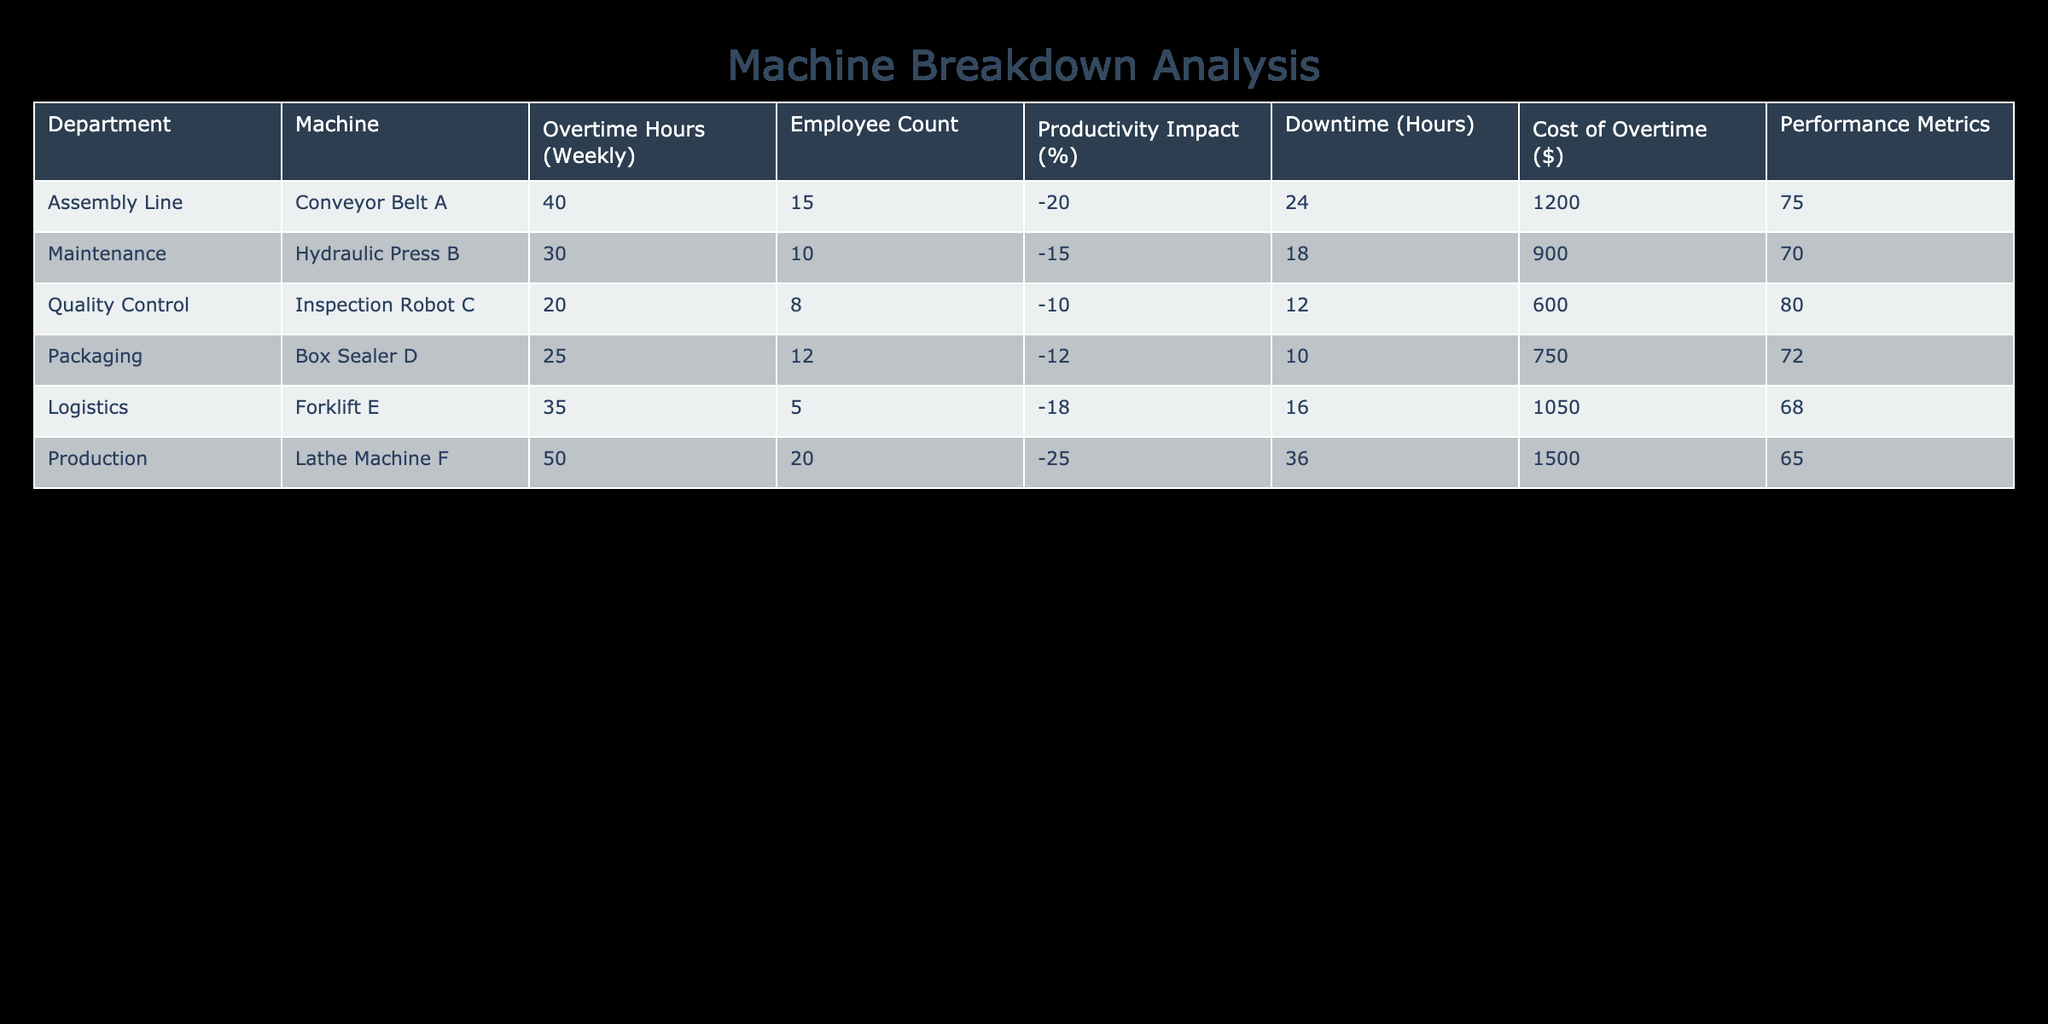What is the productivity impact percentage of the Assembly Line department? The table shows that the Assembly Line department has a productivity impact of -20%. This is directly referenced in the table under the "Productivity Impact (%)" column for the "Assembly Line" row.
Answer: -20% How many overtime hours did the Production department incur weekly? The table indicates that the Production department incurred 50 overtime hours weekly, as seen in the "Overtime Hours (Weekly)" column for the "Production" row.
Answer: 50 Which department experienced the highest cost of overtime? The highest cost of overtime listed in the table is for the Production department, amounting to $1500. This can be determined by comparing the values in the "Cost of Overtime ($)" column across all departments.
Answer: 1500 If we average the productivity impact percentages of all departments, what is the average? First, we gather the productivity impact percentages: -20, -15, -10, -12, -18, and -25. Summing these gives -110. We then divide this by the number of departments (6), resulting in an average of -18.33%.
Answer: -18.33% Does the Maintenance department have a higher productivity impact than the Logistics department? The Maintenance department has a productivity impact of -15%, while the Logistics department has -18%. Since -15 is greater than -18, the statement is true.
Answer: Yes What is the total downtime hours accumulated across all machines? The downtime hours for each machine are 24 (Conveyor Belt A), 18 (Hydraulic Press B), 12 (Inspection Robot C), 10 (Box Sealer D), 16 (Forklift E), and 36 (Lathe Machine F). Summing these: 24 + 18 + 12 + 10 + 16 + 36 = 116 hours.
Answer: 116 Is the number of employees in the Packaging department less than that in the Maintenance department? The Packaging department has 12 employees while Maintenance has 10 employees. Since 12 is greater than 10, the statement is false.
Answer: No Which department had the least downtime during repairs? By inspecting the “Downtime (Hours)” column, we see that the Packaging department had the least downtime of 10 hours, which is the smallest value compared to the others.
Answer: 10 What is the difference between the overtime hours of the Assembly Line and the Quality Control departments? The overtime hours for Assembly Line are 40, and for Quality Control, it is 20. To find the difference: 40 - 20 = 20 hours.
Answer: 20 